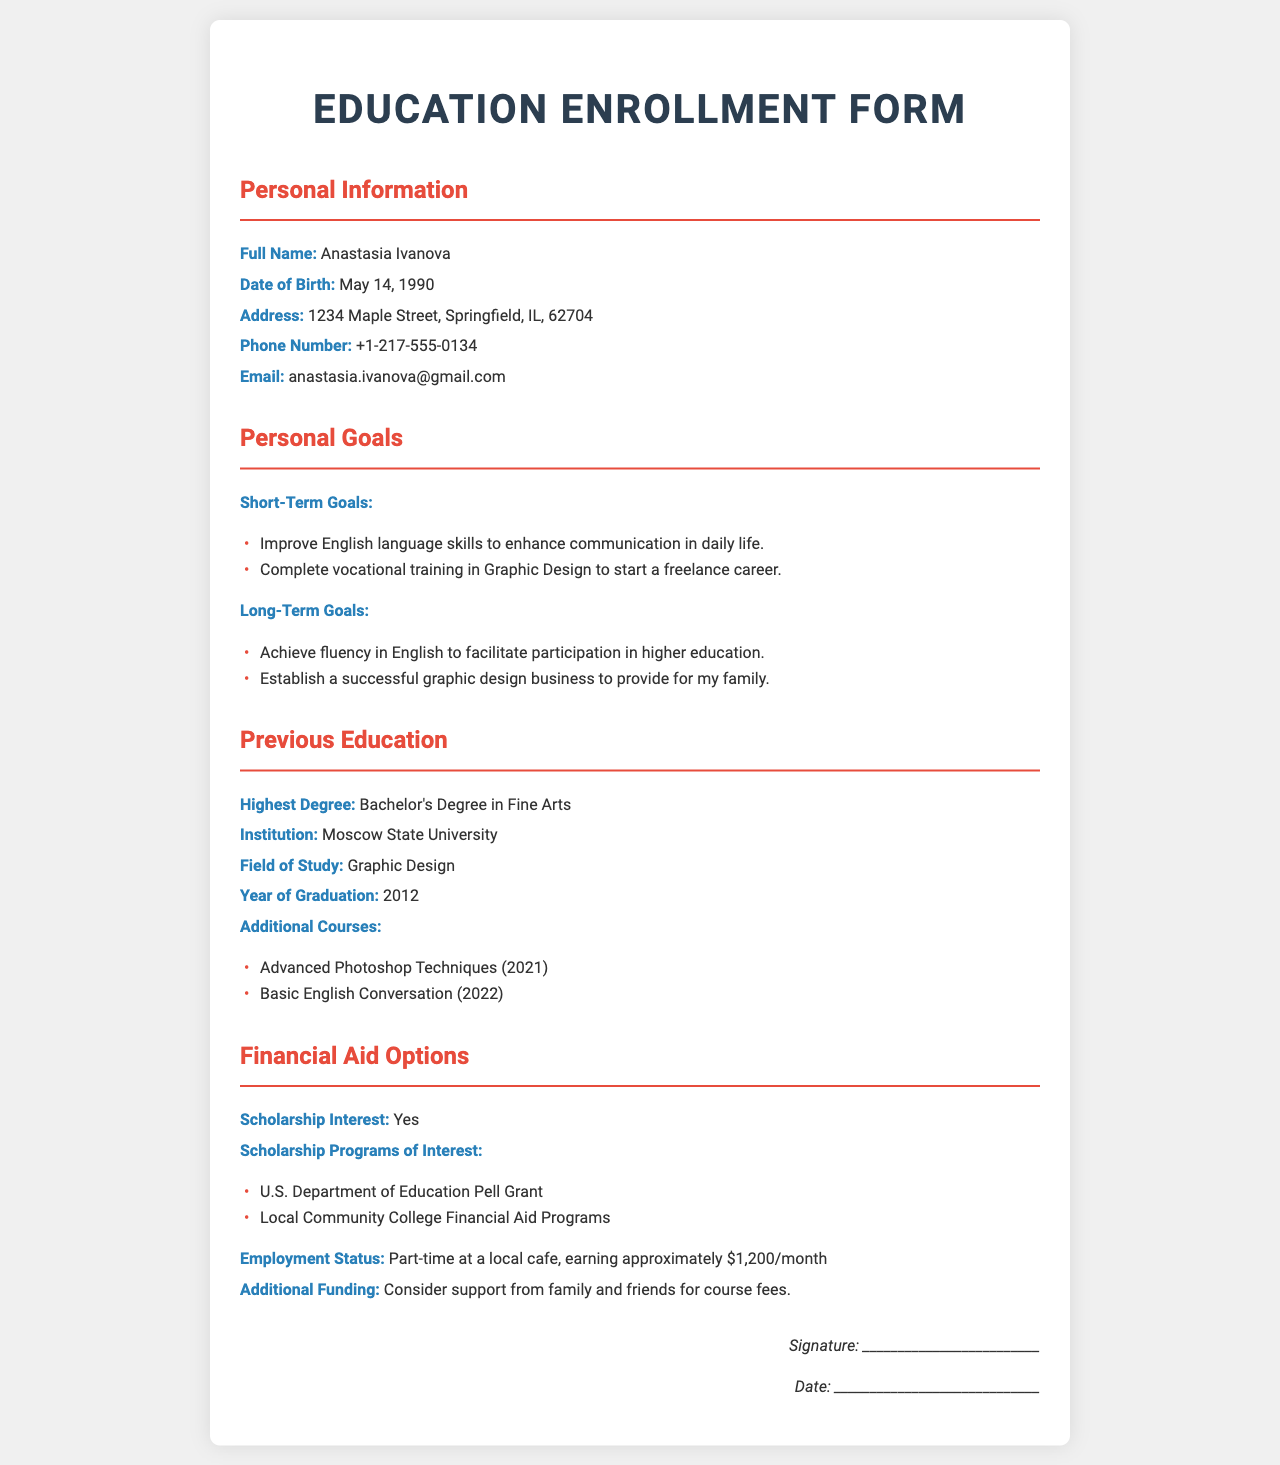What is the full name of the applicant? The document lists the applicant's full name as "Anastasia Ivanova."
Answer: Anastasia Ivanova When was Anastasia Ivanova born? The birth date provided in the document is May 14, 1990.
Answer: May 14, 1990 What is the highest degree obtained by Anastasia? The document states that Anastasia holds a Bachelor's Degree in Fine Arts.
Answer: Bachelor's Degree in Fine Arts What is Anastasia's short-term goal related to language? One of her short-term goals is to improve English language skills.
Answer: Improve English language skills Which scholarship program is Anastasia interested in? The document states her interest in the U.S. Department of Education Pell Grant.
Answer: U.S. Department of Education Pell Grant What year did Anastasia graduate? According to the form, Anastasia graduated in 2012.
Answer: 2012 What is Anastasia's current employment status? The document mentions she is working part-time at a local cafe.
Answer: Part-time at a local cafe What is the estimated monthly income of Anastasia? The document states that she is earning approximately $1,200 per month.
Answer: $1,200 What type of training is Anastasia pursuing? The document indicates she is completing vocational training in Graphic Design.
Answer: Graphic Design 